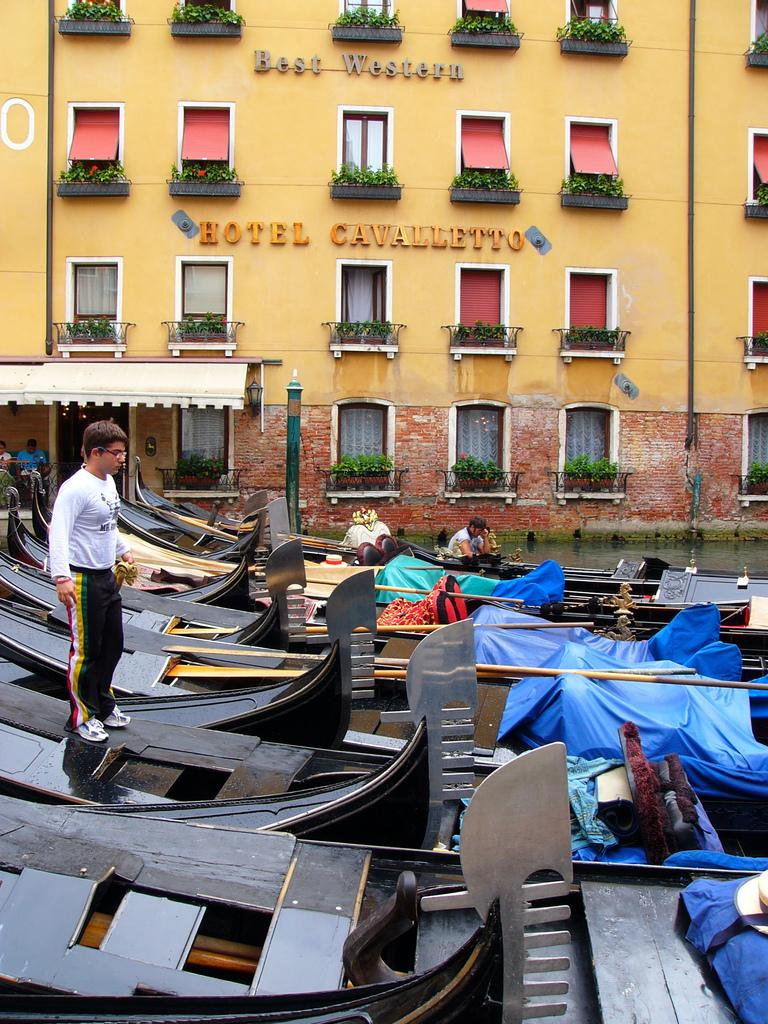What type of vehicles are at the bottom of the image? There are boats at the bottom of the image. What are the people on the boats doing? People are standing and sitting on the boats. What structure is located at the top of the image? There is a building at the top of the image. What type of natural elements can be seen in the image? There are plants in the image. What type of ice can be seen melting on the boats in the image? There is no ice present in the image; it features boats with people on them. How many needles are visible in the image? There are no needles present in the image. 